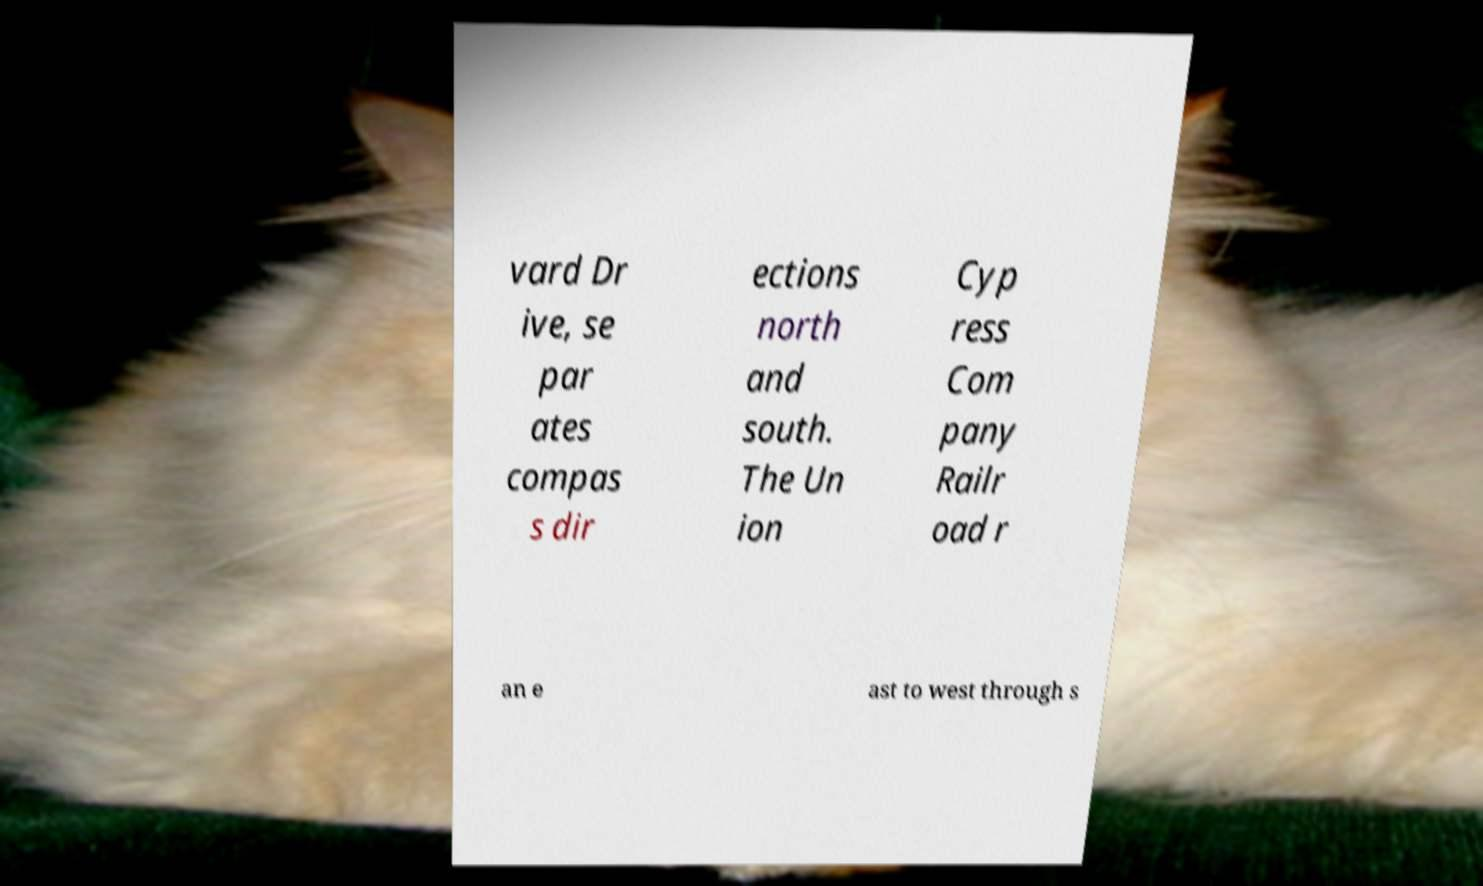Please read and relay the text visible in this image. What does it say? vard Dr ive, se par ates compas s dir ections north and south. The Un ion Cyp ress Com pany Railr oad r an e ast to west through s 